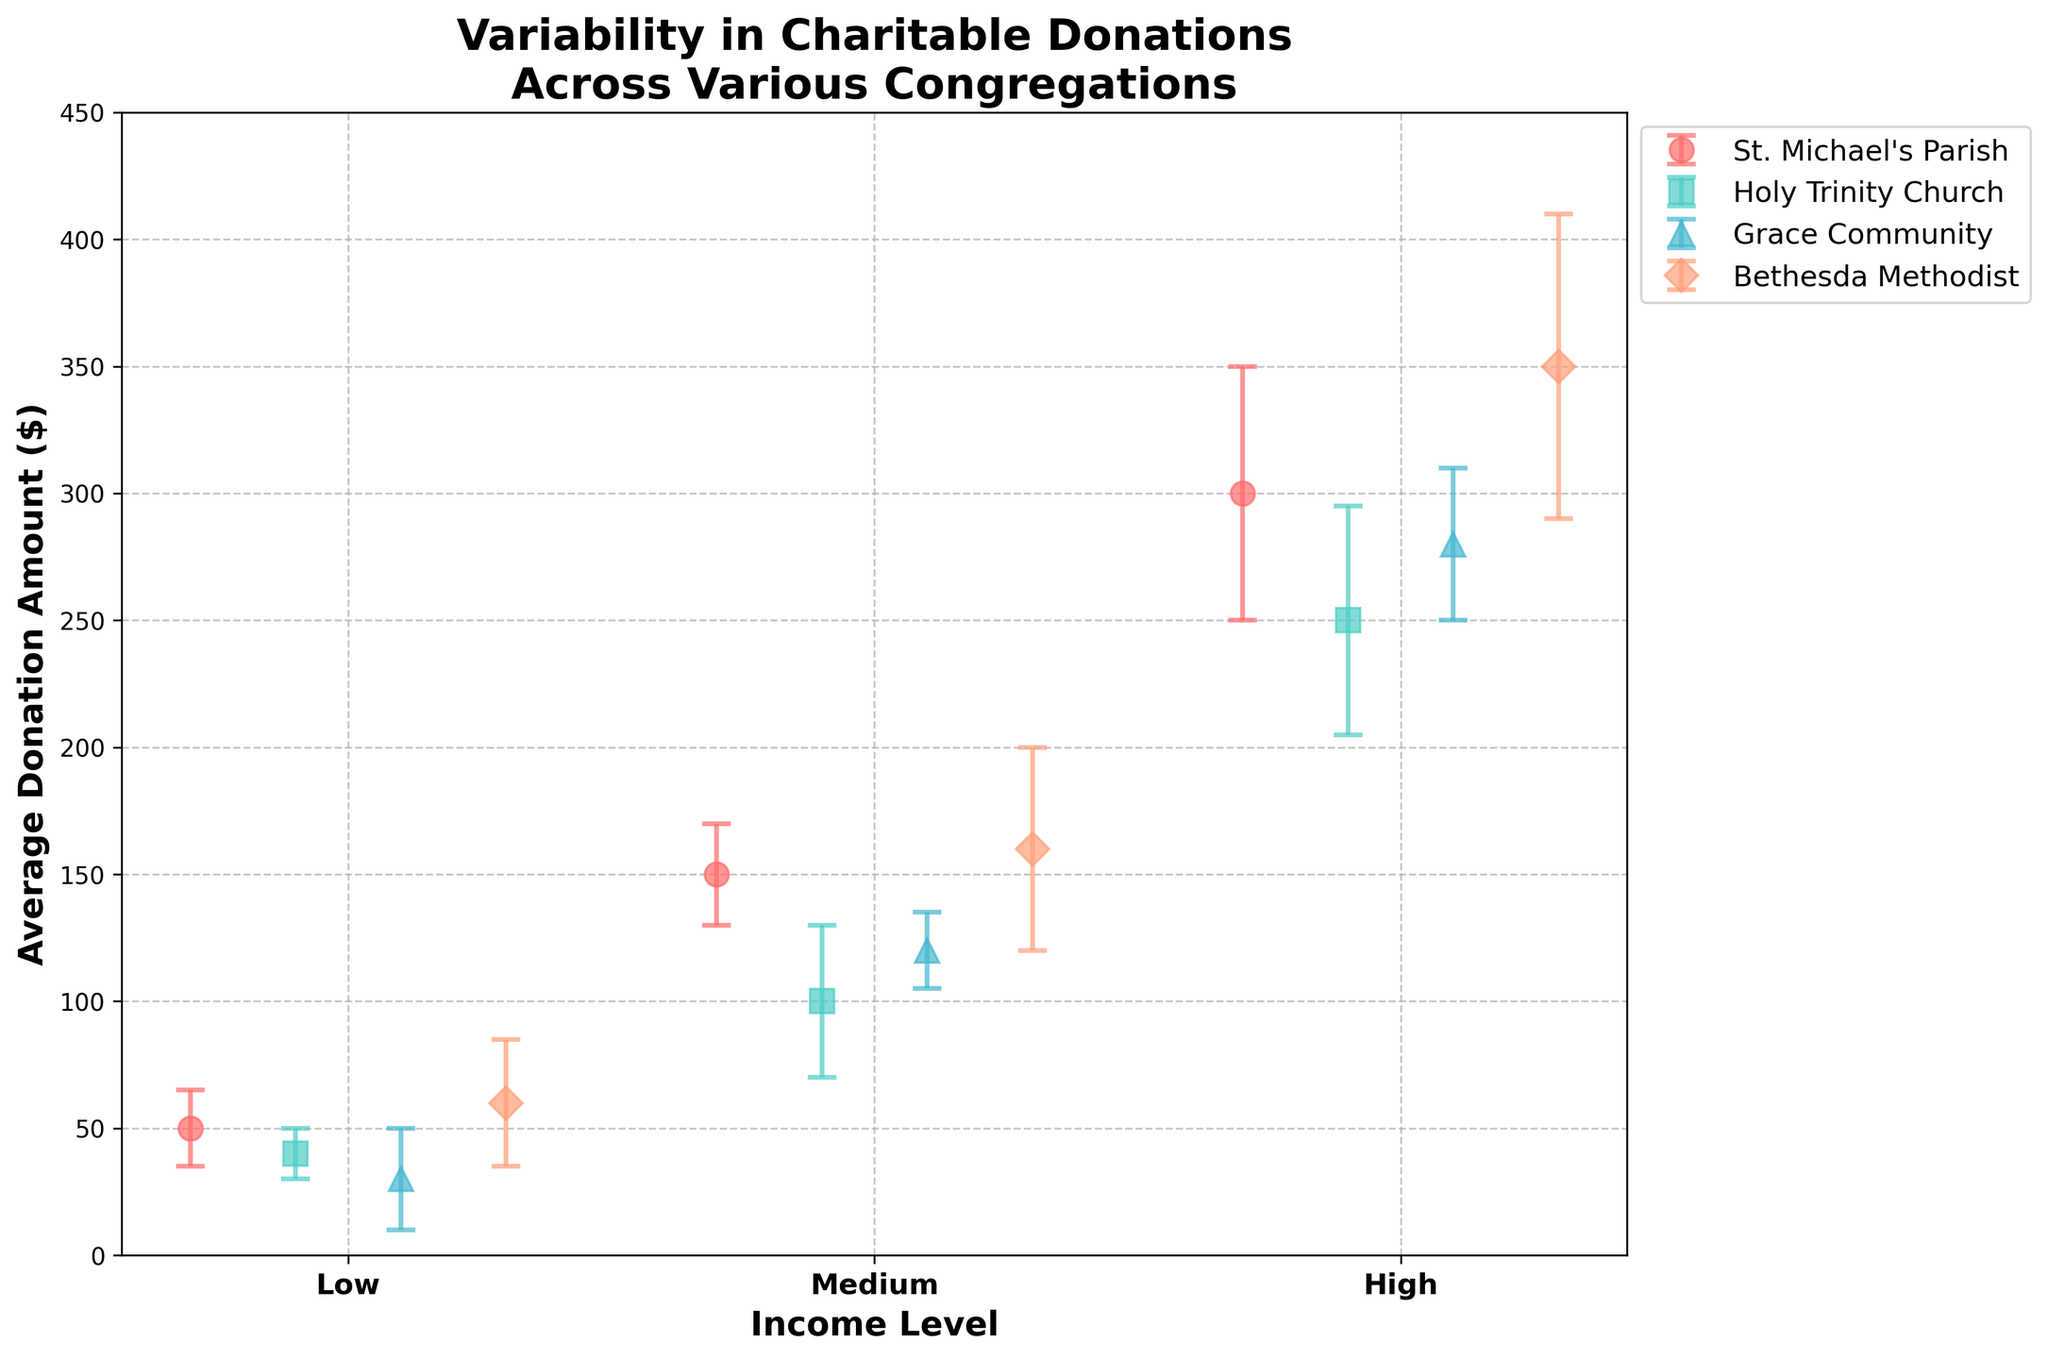What is the title of the plot? The title is written at the top of the plot and it usually summarizes the main point or content of the plot.
Answer: Variability in Charitable Donations Across Various Congregations What are the income levels represented in the plot? The income levels are labeled on the x-axis. They are presented in three categories.
Answer: Low, Medium, High Which congregation has the highest average donation amount for the high-income level? By looking at the markers for the high-income level category on the x-axis and comparing their heights, the tallest marker represents the highest average donation amount.
Answer: Bethesda Methodist How does the donation variability of Grace Community compare between the low and high-income levels? For Grace Community, look at the error bars (vertical lines) on the low and high points on the x-axis and compare their lengths.
Answer: Low: 20, High: 30 Which congregation shows the smallest variability in donations for the medium income level? Observe the medium income level data points and compare the lengths of their error bars. The shortest error bar indicates the smallest variability.
Answer: Grace Community Which income level at St. Michael's Parish has the highest average donation amount? Examine the data points for St. Michael's Parish across the low, medium, and high-income levels, and determine which marker is the highest.
Answer: High What is the difference in average donation amount between Bethesda Methodist and Holy Trinity Church at the medium-income level? Find the medium-income level data points for both congregations and calculate the difference between their average donation amounts.
Answer: 160 - 100 = 60 Between St. Michael's Parish and Grace Community, which one has a lower average donation amount for the low-income level, and by how much? Compare the low-income level data points for both congregations and find the difference.
Answer: Grace Community, by 20 Does Holy Trinity Church or Bethesda Methodist have higher donation variability at the high-income level? Compare the lengths of the error bars at high-income level data points for both congregations.
Answer: Bethesda Methodist Considering all data points, which congregation shows the most consistent (least variable) donation amounts? Identify which congregation generally has the shortest error bars indicating less variability in donations across all income levels.
Answer: Grace Community 